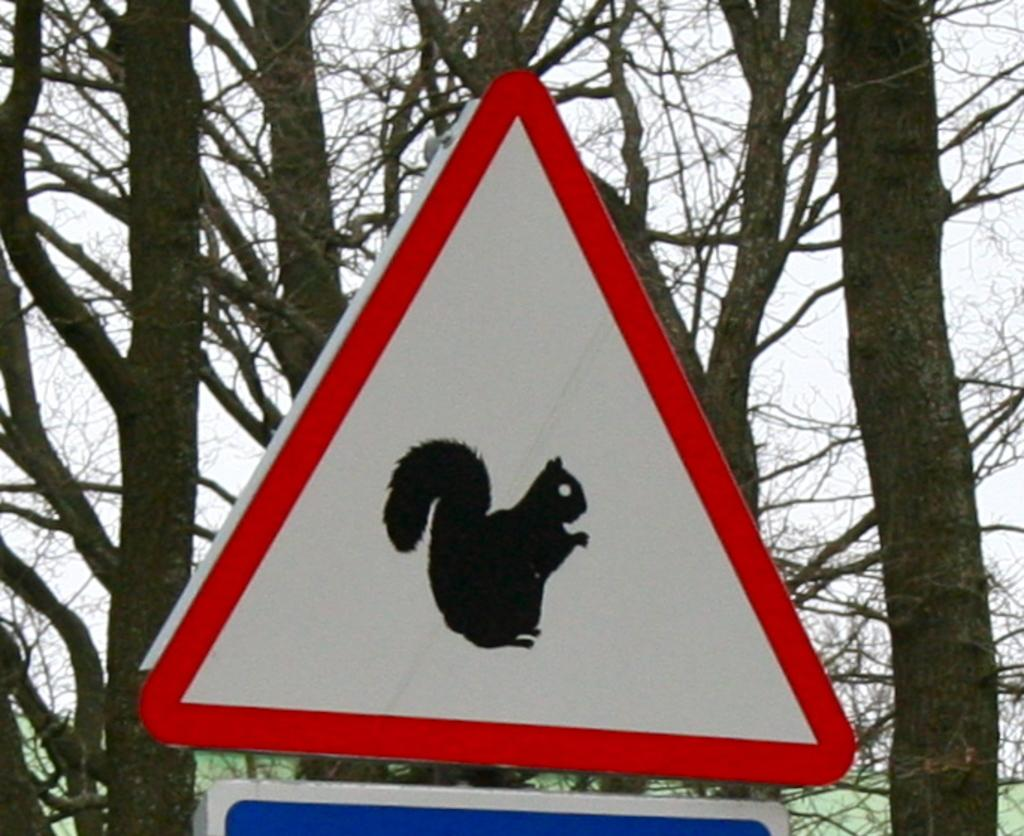What is located in the foreground of the image? There is a sign board in the foreground of the image. What can be seen in the background of the image? There are trees in the background of the image. What is the condition of the sky in the image? The sky is clear in the image. Where is the secretary sitting on the throne in the image? There is no secretary or throne present in the image. What type of sticks are being used to create the image? The image is not created with sticks; it is a photograph or digital image. 